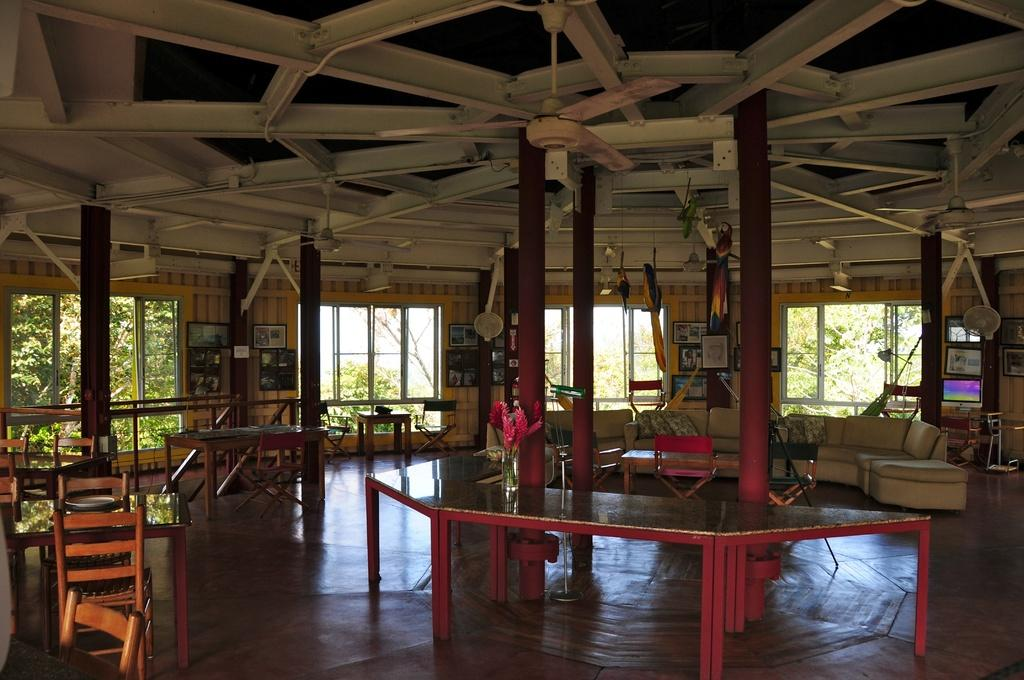What type of furniture is located on the right side of the image? There is a sofa on the right side of the image. What can be seen on the ceiling in the image? The ceiling has a fan in the image. What type of area is depicted in the image? The image appears to be taken in a breakout area. What type of furniture is present in the image besides the sofa? There are tables and chairs in the image. What type of crate is visible in the image? There is no crate present in the image. What type of lunch is being served in the image? There is no lunch being served in the image. 